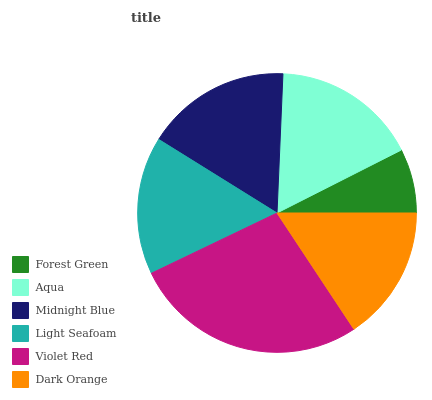Is Forest Green the minimum?
Answer yes or no. Yes. Is Violet Red the maximum?
Answer yes or no. Yes. Is Aqua the minimum?
Answer yes or no. No. Is Aqua the maximum?
Answer yes or no. No. Is Aqua greater than Forest Green?
Answer yes or no. Yes. Is Forest Green less than Aqua?
Answer yes or no. Yes. Is Forest Green greater than Aqua?
Answer yes or no. No. Is Aqua less than Forest Green?
Answer yes or no. No. Is Midnight Blue the high median?
Answer yes or no. Yes. Is Light Seafoam the low median?
Answer yes or no. Yes. Is Forest Green the high median?
Answer yes or no. No. Is Dark Orange the low median?
Answer yes or no. No. 